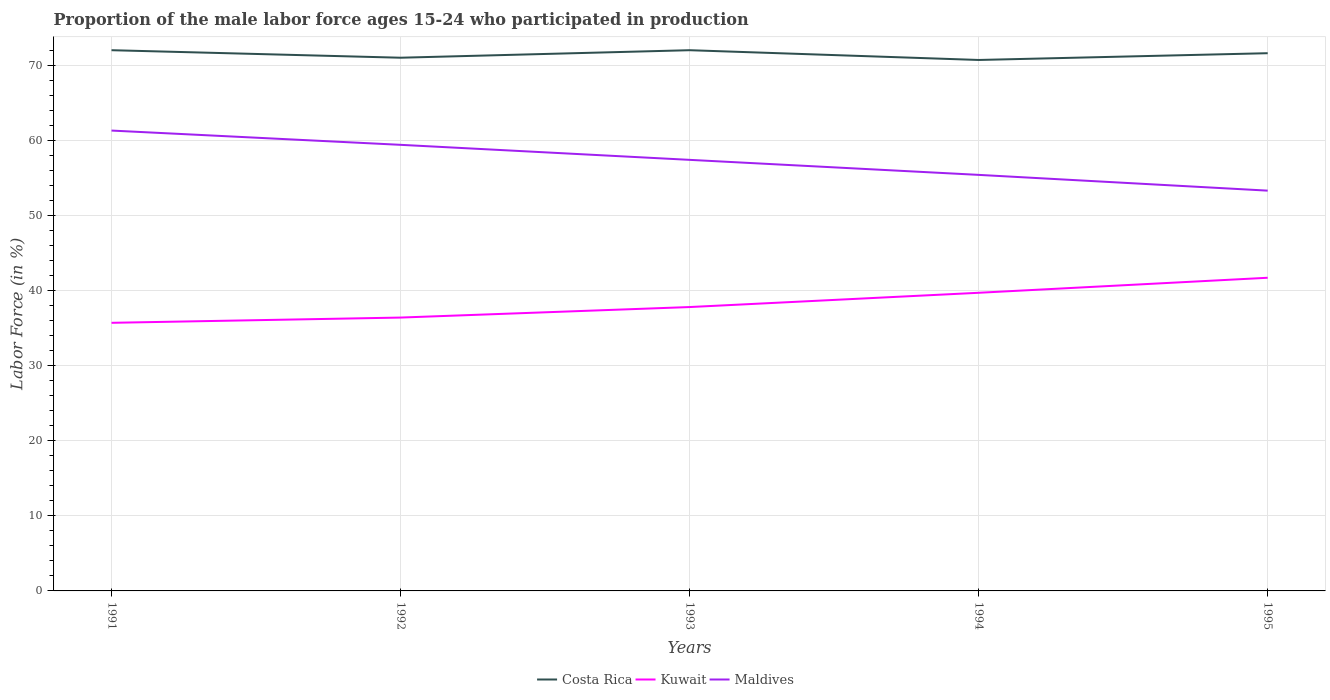How many different coloured lines are there?
Keep it short and to the point. 3. Across all years, what is the maximum proportion of the male labor force who participated in production in Maldives?
Your answer should be very brief. 53.3. In which year was the proportion of the male labor force who participated in production in Maldives maximum?
Offer a terse response. 1995. What is the total proportion of the male labor force who participated in production in Kuwait in the graph?
Give a very brief answer. -1.4. What is the difference between the highest and the second highest proportion of the male labor force who participated in production in Costa Rica?
Provide a succinct answer. 1.3. Is the proportion of the male labor force who participated in production in Kuwait strictly greater than the proportion of the male labor force who participated in production in Costa Rica over the years?
Give a very brief answer. Yes. Does the graph contain grids?
Ensure brevity in your answer.  Yes. Where does the legend appear in the graph?
Keep it short and to the point. Bottom center. How many legend labels are there?
Your answer should be very brief. 3. How are the legend labels stacked?
Offer a very short reply. Horizontal. What is the title of the graph?
Make the answer very short. Proportion of the male labor force ages 15-24 who participated in production. What is the Labor Force (in %) of Costa Rica in 1991?
Your response must be concise. 72. What is the Labor Force (in %) in Kuwait in 1991?
Give a very brief answer. 35.7. What is the Labor Force (in %) in Maldives in 1991?
Provide a short and direct response. 61.3. What is the Labor Force (in %) in Kuwait in 1992?
Keep it short and to the point. 36.4. What is the Labor Force (in %) in Maldives in 1992?
Your answer should be very brief. 59.4. What is the Labor Force (in %) in Kuwait in 1993?
Provide a short and direct response. 37.8. What is the Labor Force (in %) in Maldives in 1993?
Your answer should be very brief. 57.4. What is the Labor Force (in %) in Costa Rica in 1994?
Provide a succinct answer. 70.7. What is the Labor Force (in %) of Kuwait in 1994?
Provide a short and direct response. 39.7. What is the Labor Force (in %) in Maldives in 1994?
Your response must be concise. 55.4. What is the Labor Force (in %) in Costa Rica in 1995?
Provide a succinct answer. 71.6. What is the Labor Force (in %) in Kuwait in 1995?
Offer a very short reply. 41.7. What is the Labor Force (in %) of Maldives in 1995?
Ensure brevity in your answer.  53.3. Across all years, what is the maximum Labor Force (in %) of Kuwait?
Keep it short and to the point. 41.7. Across all years, what is the maximum Labor Force (in %) in Maldives?
Your answer should be compact. 61.3. Across all years, what is the minimum Labor Force (in %) in Costa Rica?
Your response must be concise. 70.7. Across all years, what is the minimum Labor Force (in %) in Kuwait?
Keep it short and to the point. 35.7. Across all years, what is the minimum Labor Force (in %) in Maldives?
Offer a terse response. 53.3. What is the total Labor Force (in %) in Costa Rica in the graph?
Ensure brevity in your answer.  357.3. What is the total Labor Force (in %) in Kuwait in the graph?
Offer a terse response. 191.3. What is the total Labor Force (in %) in Maldives in the graph?
Provide a succinct answer. 286.8. What is the difference between the Labor Force (in %) of Costa Rica in 1991 and that in 1992?
Offer a very short reply. 1. What is the difference between the Labor Force (in %) of Kuwait in 1991 and that in 1992?
Your answer should be very brief. -0.7. What is the difference between the Labor Force (in %) of Maldives in 1991 and that in 1993?
Offer a terse response. 3.9. What is the difference between the Labor Force (in %) in Costa Rica in 1991 and that in 1995?
Your answer should be very brief. 0.4. What is the difference between the Labor Force (in %) in Maldives in 1991 and that in 1995?
Your answer should be very brief. 8. What is the difference between the Labor Force (in %) of Maldives in 1992 and that in 1994?
Make the answer very short. 4. What is the difference between the Labor Force (in %) in Costa Rica in 1992 and that in 1995?
Provide a short and direct response. -0.6. What is the difference between the Labor Force (in %) of Kuwait in 1992 and that in 1995?
Ensure brevity in your answer.  -5.3. What is the difference between the Labor Force (in %) of Costa Rica in 1993 and that in 1994?
Give a very brief answer. 1.3. What is the difference between the Labor Force (in %) in Kuwait in 1993 and that in 1994?
Keep it short and to the point. -1.9. What is the difference between the Labor Force (in %) of Kuwait in 1993 and that in 1995?
Give a very brief answer. -3.9. What is the difference between the Labor Force (in %) of Costa Rica in 1991 and the Labor Force (in %) of Kuwait in 1992?
Your response must be concise. 35.6. What is the difference between the Labor Force (in %) of Costa Rica in 1991 and the Labor Force (in %) of Maldives in 1992?
Your response must be concise. 12.6. What is the difference between the Labor Force (in %) of Kuwait in 1991 and the Labor Force (in %) of Maldives in 1992?
Give a very brief answer. -23.7. What is the difference between the Labor Force (in %) of Costa Rica in 1991 and the Labor Force (in %) of Kuwait in 1993?
Offer a terse response. 34.2. What is the difference between the Labor Force (in %) of Costa Rica in 1991 and the Labor Force (in %) of Maldives in 1993?
Provide a short and direct response. 14.6. What is the difference between the Labor Force (in %) in Kuwait in 1991 and the Labor Force (in %) in Maldives in 1993?
Give a very brief answer. -21.7. What is the difference between the Labor Force (in %) of Costa Rica in 1991 and the Labor Force (in %) of Kuwait in 1994?
Offer a very short reply. 32.3. What is the difference between the Labor Force (in %) in Kuwait in 1991 and the Labor Force (in %) in Maldives in 1994?
Provide a succinct answer. -19.7. What is the difference between the Labor Force (in %) of Costa Rica in 1991 and the Labor Force (in %) of Kuwait in 1995?
Provide a short and direct response. 30.3. What is the difference between the Labor Force (in %) in Costa Rica in 1991 and the Labor Force (in %) in Maldives in 1995?
Your response must be concise. 18.7. What is the difference between the Labor Force (in %) in Kuwait in 1991 and the Labor Force (in %) in Maldives in 1995?
Offer a very short reply. -17.6. What is the difference between the Labor Force (in %) in Costa Rica in 1992 and the Labor Force (in %) in Kuwait in 1993?
Keep it short and to the point. 33.2. What is the difference between the Labor Force (in %) in Costa Rica in 1992 and the Labor Force (in %) in Maldives in 1993?
Make the answer very short. 13.6. What is the difference between the Labor Force (in %) of Costa Rica in 1992 and the Labor Force (in %) of Kuwait in 1994?
Make the answer very short. 31.3. What is the difference between the Labor Force (in %) of Costa Rica in 1992 and the Labor Force (in %) of Maldives in 1994?
Ensure brevity in your answer.  15.6. What is the difference between the Labor Force (in %) of Kuwait in 1992 and the Labor Force (in %) of Maldives in 1994?
Offer a terse response. -19. What is the difference between the Labor Force (in %) of Costa Rica in 1992 and the Labor Force (in %) of Kuwait in 1995?
Your response must be concise. 29.3. What is the difference between the Labor Force (in %) in Costa Rica in 1992 and the Labor Force (in %) in Maldives in 1995?
Ensure brevity in your answer.  17.7. What is the difference between the Labor Force (in %) in Kuwait in 1992 and the Labor Force (in %) in Maldives in 1995?
Ensure brevity in your answer.  -16.9. What is the difference between the Labor Force (in %) in Costa Rica in 1993 and the Labor Force (in %) in Kuwait in 1994?
Give a very brief answer. 32.3. What is the difference between the Labor Force (in %) of Costa Rica in 1993 and the Labor Force (in %) of Maldives in 1994?
Your answer should be very brief. 16.6. What is the difference between the Labor Force (in %) in Kuwait in 1993 and the Labor Force (in %) in Maldives in 1994?
Offer a terse response. -17.6. What is the difference between the Labor Force (in %) in Costa Rica in 1993 and the Labor Force (in %) in Kuwait in 1995?
Offer a very short reply. 30.3. What is the difference between the Labor Force (in %) in Kuwait in 1993 and the Labor Force (in %) in Maldives in 1995?
Offer a terse response. -15.5. What is the difference between the Labor Force (in %) of Costa Rica in 1994 and the Labor Force (in %) of Kuwait in 1995?
Ensure brevity in your answer.  29. What is the difference between the Labor Force (in %) of Kuwait in 1994 and the Labor Force (in %) of Maldives in 1995?
Make the answer very short. -13.6. What is the average Labor Force (in %) of Costa Rica per year?
Provide a short and direct response. 71.46. What is the average Labor Force (in %) of Kuwait per year?
Ensure brevity in your answer.  38.26. What is the average Labor Force (in %) in Maldives per year?
Your answer should be very brief. 57.36. In the year 1991, what is the difference between the Labor Force (in %) of Costa Rica and Labor Force (in %) of Kuwait?
Your answer should be very brief. 36.3. In the year 1991, what is the difference between the Labor Force (in %) of Kuwait and Labor Force (in %) of Maldives?
Your answer should be compact. -25.6. In the year 1992, what is the difference between the Labor Force (in %) of Costa Rica and Labor Force (in %) of Kuwait?
Your answer should be very brief. 34.6. In the year 1993, what is the difference between the Labor Force (in %) of Costa Rica and Labor Force (in %) of Kuwait?
Ensure brevity in your answer.  34.2. In the year 1993, what is the difference between the Labor Force (in %) in Kuwait and Labor Force (in %) in Maldives?
Offer a terse response. -19.6. In the year 1994, what is the difference between the Labor Force (in %) of Costa Rica and Labor Force (in %) of Kuwait?
Keep it short and to the point. 31. In the year 1994, what is the difference between the Labor Force (in %) of Kuwait and Labor Force (in %) of Maldives?
Your answer should be very brief. -15.7. In the year 1995, what is the difference between the Labor Force (in %) of Costa Rica and Labor Force (in %) of Kuwait?
Provide a short and direct response. 29.9. In the year 1995, what is the difference between the Labor Force (in %) of Kuwait and Labor Force (in %) of Maldives?
Your answer should be compact. -11.6. What is the ratio of the Labor Force (in %) in Costa Rica in 1991 to that in 1992?
Provide a short and direct response. 1.01. What is the ratio of the Labor Force (in %) in Kuwait in 1991 to that in 1992?
Your answer should be very brief. 0.98. What is the ratio of the Labor Force (in %) of Maldives in 1991 to that in 1992?
Offer a terse response. 1.03. What is the ratio of the Labor Force (in %) in Maldives in 1991 to that in 1993?
Your answer should be compact. 1.07. What is the ratio of the Labor Force (in %) of Costa Rica in 1991 to that in 1994?
Your answer should be compact. 1.02. What is the ratio of the Labor Force (in %) in Kuwait in 1991 to that in 1994?
Your response must be concise. 0.9. What is the ratio of the Labor Force (in %) of Maldives in 1991 to that in 1994?
Provide a short and direct response. 1.11. What is the ratio of the Labor Force (in %) of Costa Rica in 1991 to that in 1995?
Your response must be concise. 1.01. What is the ratio of the Labor Force (in %) of Kuwait in 1991 to that in 1995?
Provide a succinct answer. 0.86. What is the ratio of the Labor Force (in %) in Maldives in 1991 to that in 1995?
Offer a very short reply. 1.15. What is the ratio of the Labor Force (in %) of Costa Rica in 1992 to that in 1993?
Keep it short and to the point. 0.99. What is the ratio of the Labor Force (in %) of Kuwait in 1992 to that in 1993?
Provide a short and direct response. 0.96. What is the ratio of the Labor Force (in %) of Maldives in 1992 to that in 1993?
Make the answer very short. 1.03. What is the ratio of the Labor Force (in %) of Costa Rica in 1992 to that in 1994?
Your response must be concise. 1. What is the ratio of the Labor Force (in %) of Kuwait in 1992 to that in 1994?
Keep it short and to the point. 0.92. What is the ratio of the Labor Force (in %) in Maldives in 1992 to that in 1994?
Make the answer very short. 1.07. What is the ratio of the Labor Force (in %) in Kuwait in 1992 to that in 1995?
Your response must be concise. 0.87. What is the ratio of the Labor Force (in %) in Maldives in 1992 to that in 1995?
Offer a very short reply. 1.11. What is the ratio of the Labor Force (in %) of Costa Rica in 1993 to that in 1994?
Provide a succinct answer. 1.02. What is the ratio of the Labor Force (in %) in Kuwait in 1993 to that in 1994?
Ensure brevity in your answer.  0.95. What is the ratio of the Labor Force (in %) of Maldives in 1993 to that in 1994?
Offer a very short reply. 1.04. What is the ratio of the Labor Force (in %) of Costa Rica in 1993 to that in 1995?
Keep it short and to the point. 1.01. What is the ratio of the Labor Force (in %) of Kuwait in 1993 to that in 1995?
Provide a succinct answer. 0.91. What is the ratio of the Labor Force (in %) of Maldives in 1993 to that in 1995?
Offer a terse response. 1.08. What is the ratio of the Labor Force (in %) in Costa Rica in 1994 to that in 1995?
Ensure brevity in your answer.  0.99. What is the ratio of the Labor Force (in %) in Kuwait in 1994 to that in 1995?
Your response must be concise. 0.95. What is the ratio of the Labor Force (in %) in Maldives in 1994 to that in 1995?
Offer a terse response. 1.04. What is the difference between the highest and the second highest Labor Force (in %) of Costa Rica?
Provide a short and direct response. 0. What is the difference between the highest and the lowest Labor Force (in %) in Kuwait?
Provide a short and direct response. 6. What is the difference between the highest and the lowest Labor Force (in %) in Maldives?
Give a very brief answer. 8. 